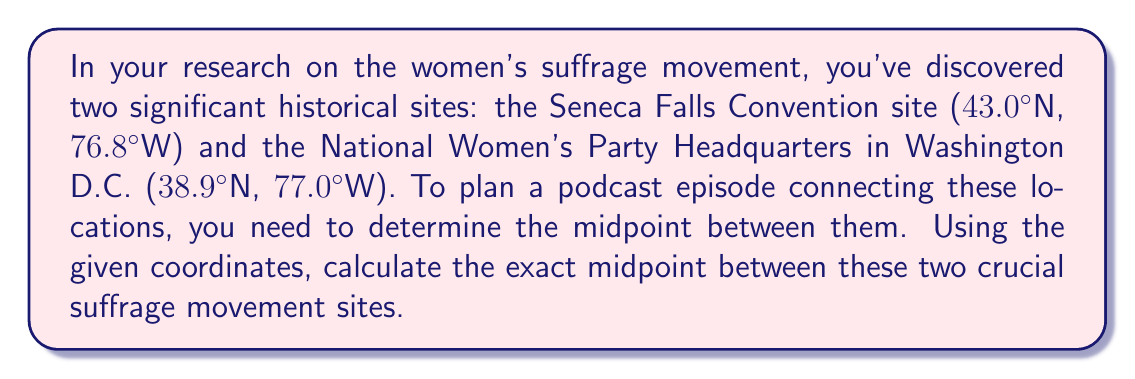What is the answer to this math problem? To find the midpoint between two points in a coordinate system, we use the midpoint formula:

$$\text{Midpoint} = \left(\frac{x_1 + x_2}{2}, \frac{y_1 + y_2}{2}\right)$$

Where $(x_1, y_1)$ is the first point and $(x_2, y_2)$ is the second point.

In this case, we're dealing with latitude and longitude coordinates:
1. Seneca Falls Convention site: (43.0°N, 76.8°W)
2. National Women's Party Headquarters: (38.9°N, 77.0°W)

Let's assign these to our variables:
$x_1 = 43.0$, $y_1 = -76.8$ (note the negative for western longitude)
$x_2 = 38.9$, $y_2 = -77.0$

Now, let's apply the midpoint formula:

For latitude (x-coordinate):
$$\frac{x_1 + x_2}{2} = \frac{43.0 + 38.9}{2} = \frac{81.9}{2} = 40.95$$

For longitude (y-coordinate):
$$\frac{y_1 + y_2}{2} = \frac{-76.8 + (-77.0)}{2} = \frac{-153.8}{2} = -76.9$$

Therefore, the midpoint is (40.95°N, 76.9°W).
Answer: The midpoint between the Seneca Falls Convention site and the National Women's Party Headquarters is (40.95°N, 76.9°W). 